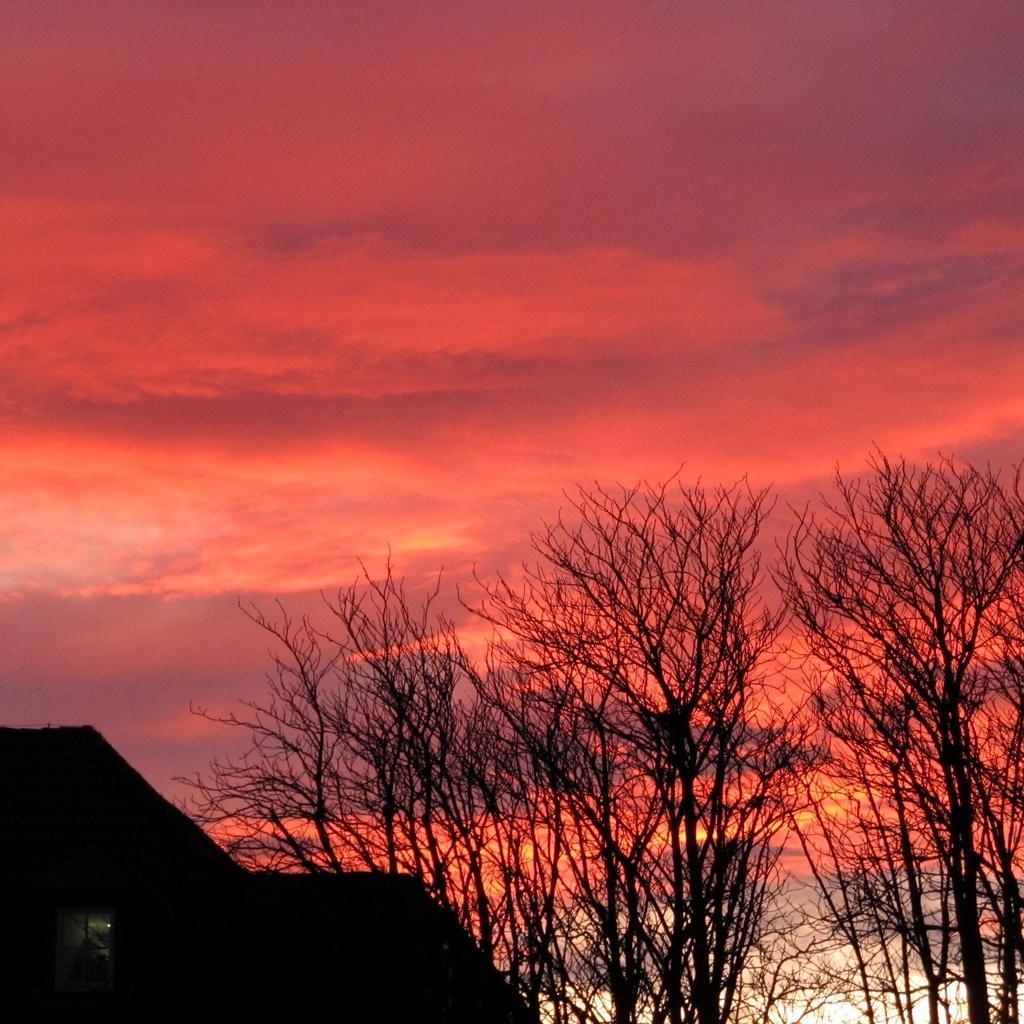Can you describe this image briefly? In this image we can see a house, a group of trees and the sky which looks cloudy. 